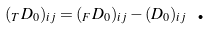<formula> <loc_0><loc_0><loc_500><loc_500>( _ { T } D _ { 0 } ) _ { i j } = ( _ { F } D _ { 0 } ) _ { i j } - ( D _ { 0 } ) _ { i j } \text { .}</formula> 